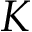<formula> <loc_0><loc_0><loc_500><loc_500>K</formula> 